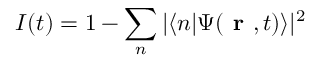Convert formula to latex. <formula><loc_0><loc_0><loc_500><loc_500>I ( t ) = 1 - \sum _ { n } | \langle n | \Psi ( r , t ) \rangle | ^ { 2 }</formula> 